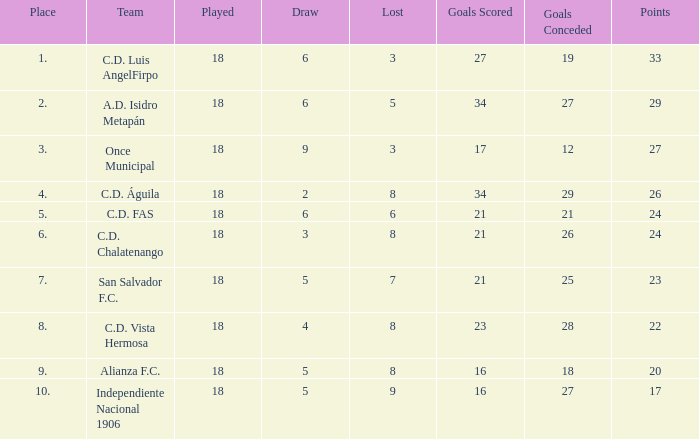For Once Municipal, what were the goals scored that had less than 27 points and greater than place 1? None. 